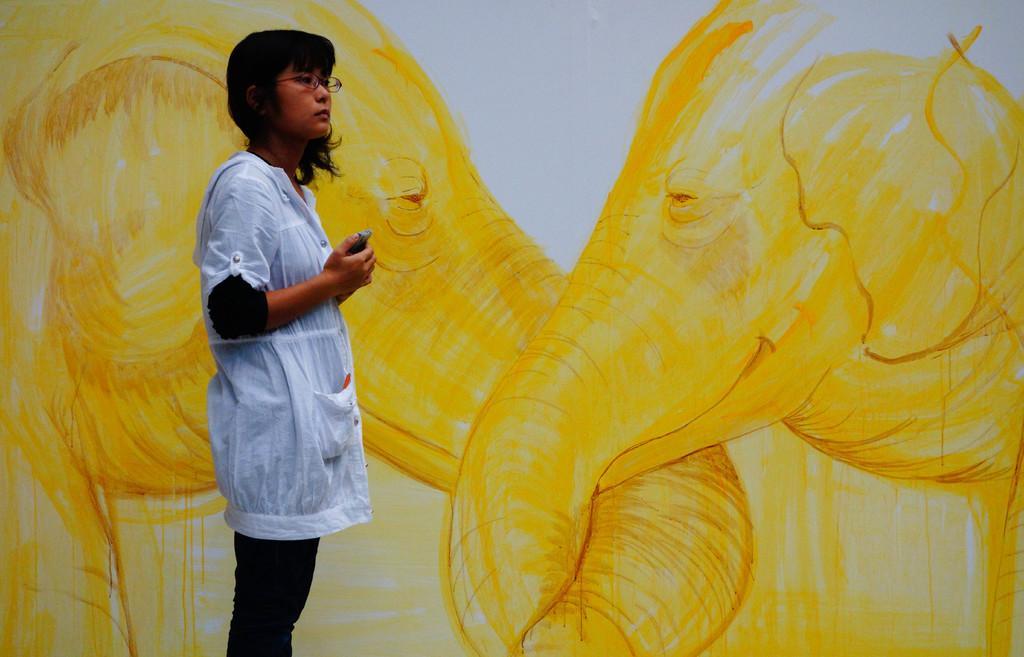Could you give a brief overview of what you see in this image? In this image, we can see an art on the wall. There is a person in the middle of the image standing and wearing clothes. 